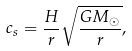Convert formula to latex. <formula><loc_0><loc_0><loc_500><loc_500>c _ { s } = \frac { H } { r } \sqrt { \frac { G M _ { \odot } } { r } } ,</formula> 